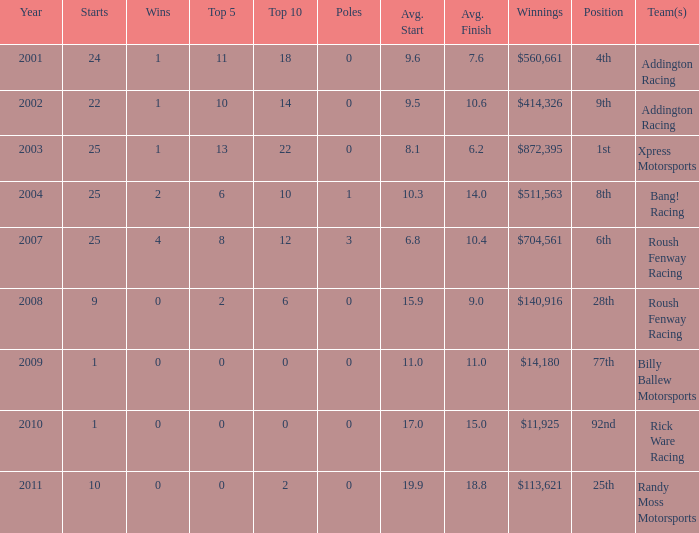How many wins in the 4th position? 1.0. 